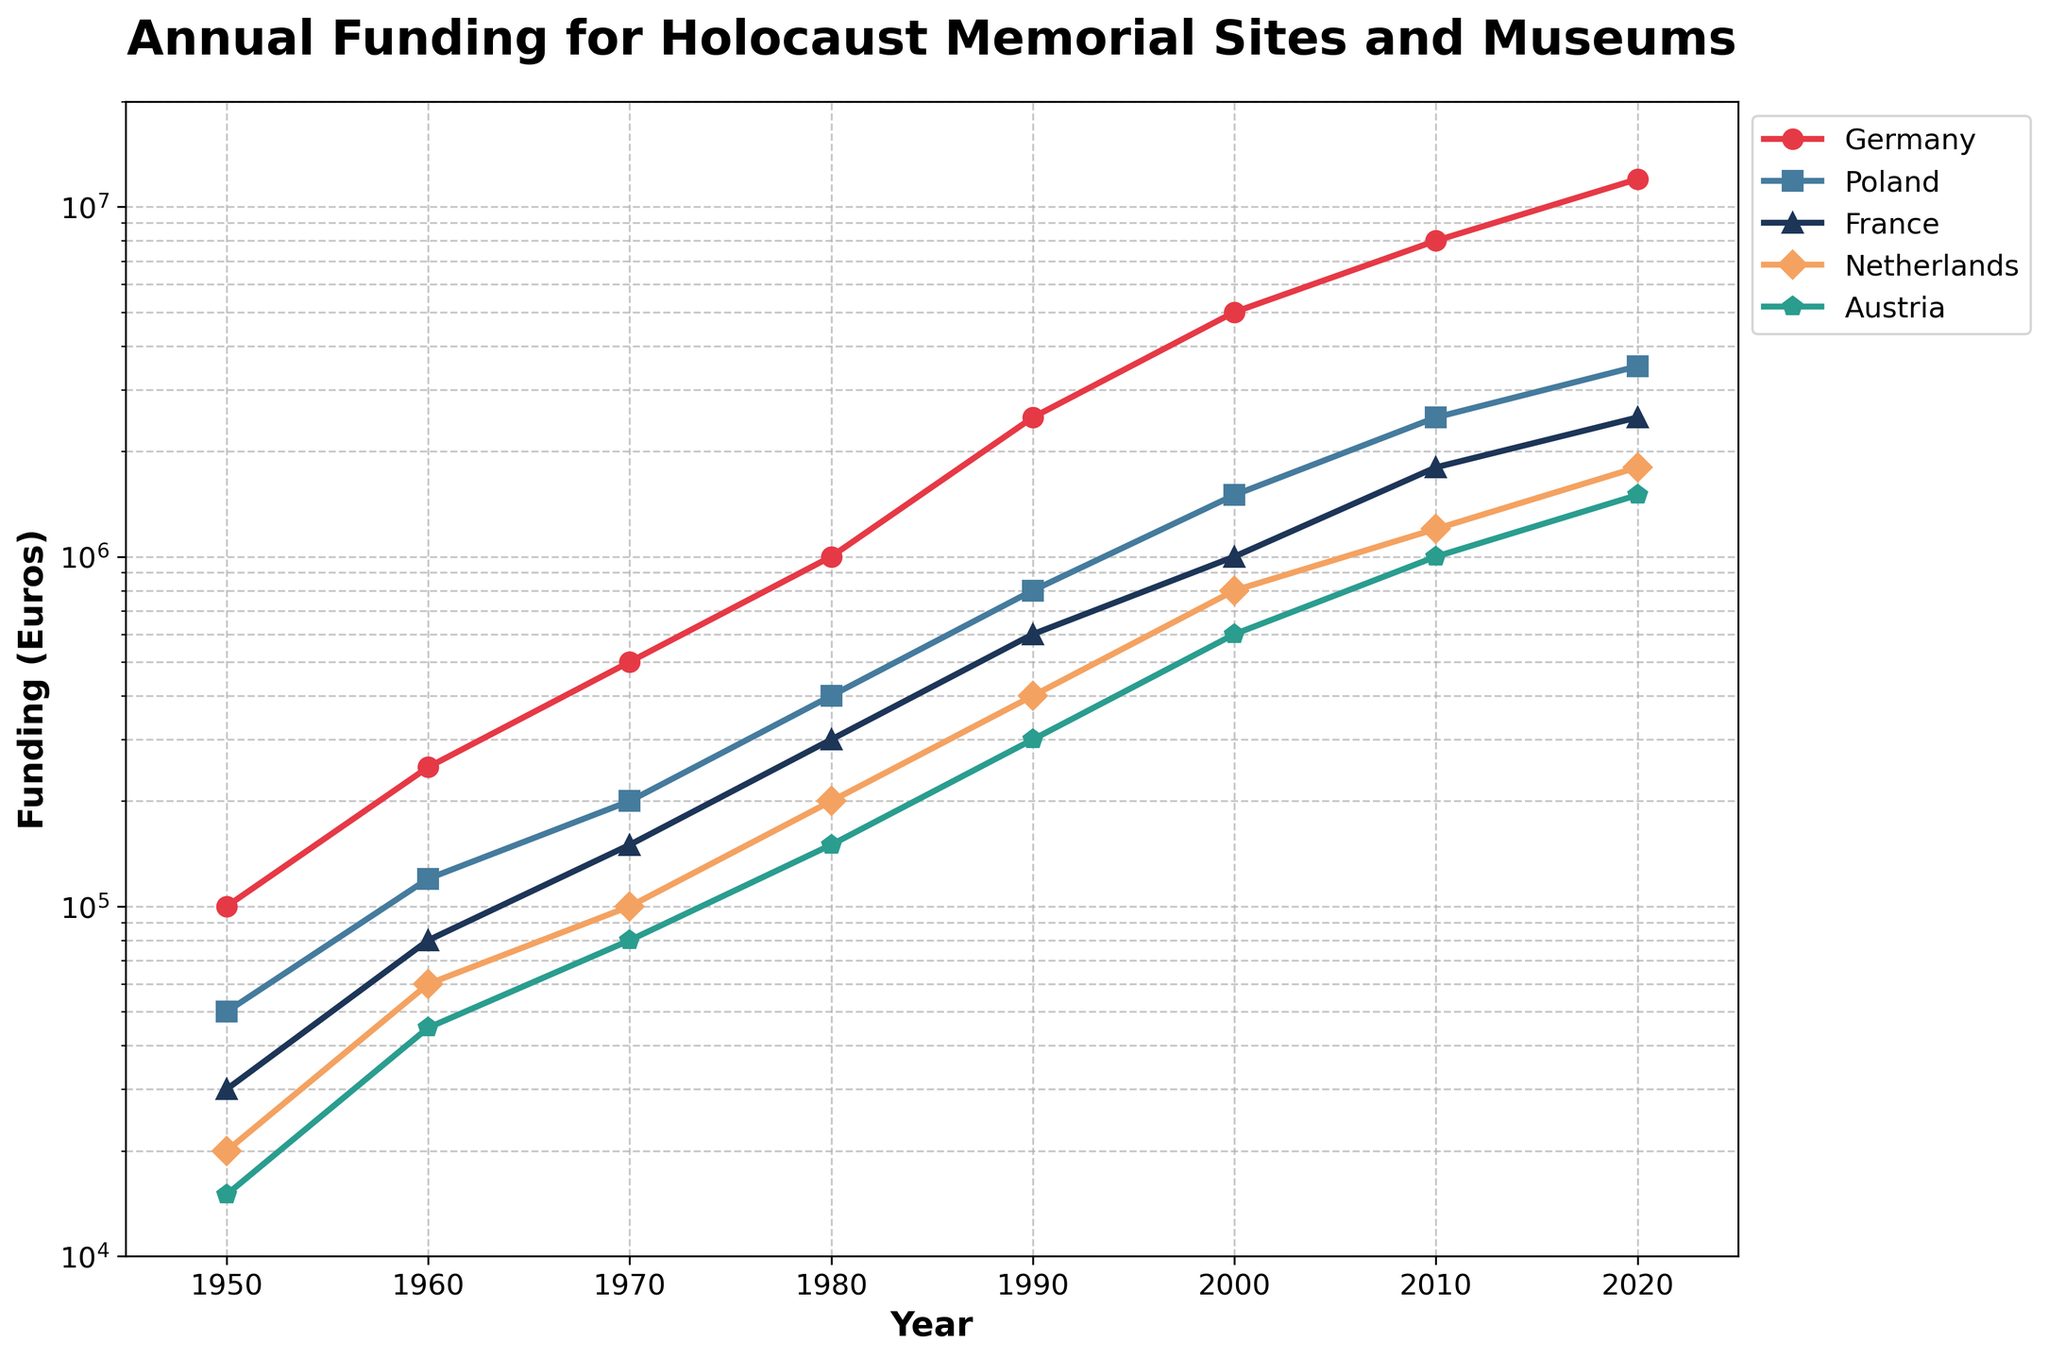What year did Germany's funding first exceed 1,000,000 Euros? Germany's funding reaches 1,000,000 Euros in 1980. The line for Germany shows its funding surpassing this amount at this point.
Answer: 1980 How does the funding for Poland in 2020 compare to that in 2000? In 2000, Poland's funding was 1,500,000 Euros, while in 2020 it was 3,500,000 Euros, showing an increase.
Answer: 3,500,000 Euros vs 1,500,000 Euros (increased) During which decade did France see the highest relative growth in funding? Comparing the increments per decade, France's funding increased dramatically from 600,000 Euros in 1990 to 1,000,000 Euros in 2000, an addition of 400,000 Euros, thus showing this as the period of highest relative growth.
Answer: 1990–2000 Which country had the smallest overall funding increase from 1950 to 2020? Austria's funding increased from 15,000 Euros in 1950 to 1,500,000 Euros in 2020, a smaller increase compared to the other countries listed.
Answer: Austria What's the combined funding for Germany and the Netherlands in 1970? Germany's funding was 500,000 Euros, and the Netherlands' funding was 100,000 Euros in 1970. Combined, this sums to 600,000 Euros.
Answer: 600,000 Euros Rank the countries by their funding levels in 2010. After checking the vertical positions of each country's line at 2010: 
1. Germany: 8,000,000 Euros, 
2. Poland: 2,500,000 Euros, 
3. France: 1,800,000 Euros, 
4. Netherlands: 1,200,000 Euros, 
5. Austria: 1,000,000 Euros.
Answer: Germany > Poland > France > Netherlands > Austria In which years did every country experience an increase in funding from the previous decade? Every country's funding increased from the previous decade in 1960, 1970, 1980, 1990, 2000, 2010, and 2020 as observed from the upward trends for each line.
Answer: 1960, 1970, 1980, 1990, 2000, 2010, 2020 What is the difference in funding between Germany and Austria in 1980? In 1980, Germany's funding was 1,000,000 Euros, and Austria's funding was 150,000 Euros. The difference is 1,000,000 - 150,000 = 850,000 Euros.
Answer: 850,000 Euros Which country shows the most dramatic increase in funding between 1990 and 2020? Germany's funding increased from 2,500,000 Euros in 1990 to 12,000,000 Euros in 2020, marking the highest increase (9,500,000 Euros) amongst all countries.
Answer: Germany 